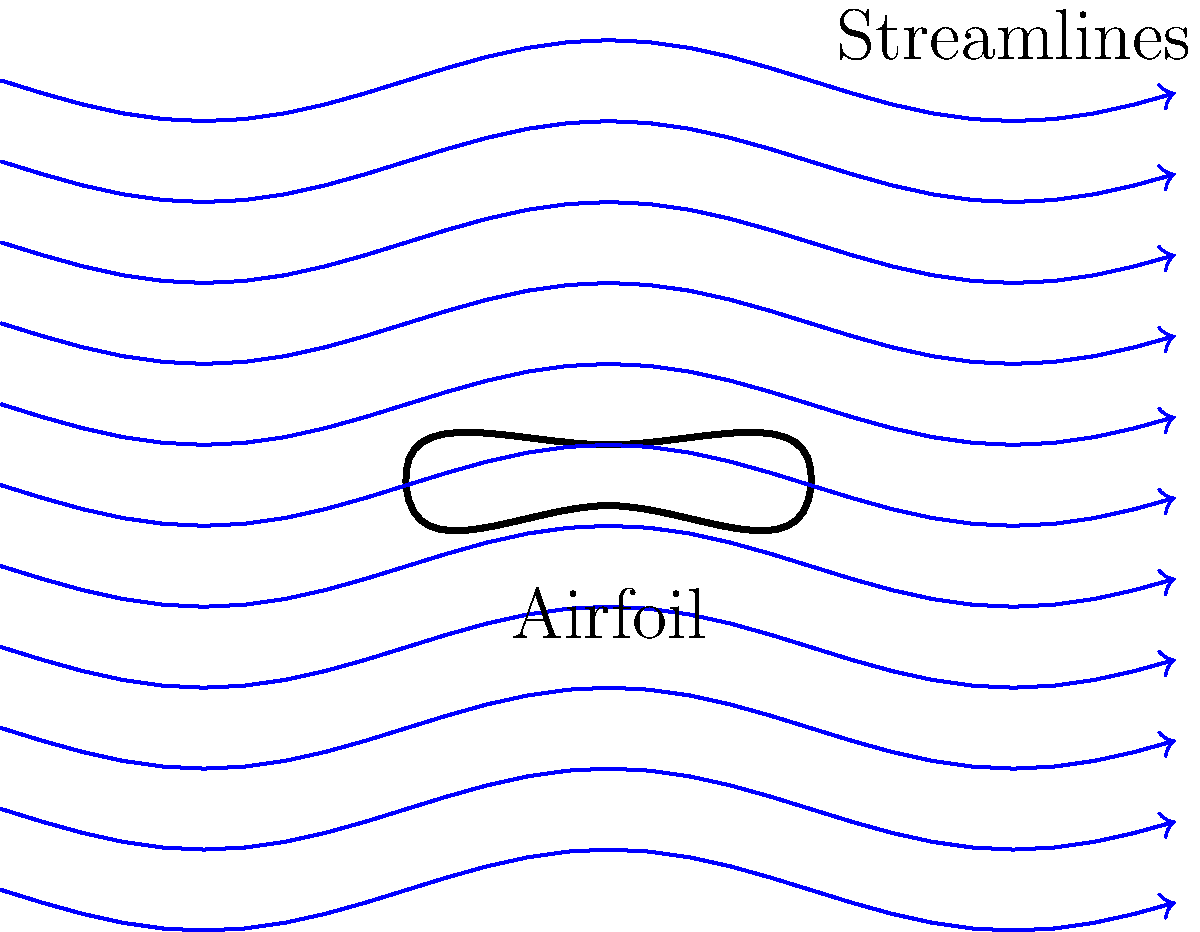In the diagram above, streamlines are used to visualize fluid flow around an airfoil. What characteristic of the streamlines near the top surface of the airfoil suggests a region of higher velocity compared to the bottom surface? To answer this question, we need to analyze the streamline patterns around the airfoil:

1. Observe the streamlines: Notice how they curve around the airfoil shape.

2. Compare top and bottom surfaces: The streamlines above the airfoil are closer together than those below.

3. Recall the continuity equation: For incompressible flow, $Q = A_1v_1 = A_2v_2$, where $Q$ is flow rate, $A$ is cross-sectional area, and $v$ is velocity.

4. Apply continuity to streamlines: When streamlines are closer together, it represents a smaller cross-sectional area ($A$).

5. Relate area to velocity: To maintain constant flow rate ($Q$), velocity ($v$) must increase as area ($A$) decreases.

6. Conclude: The closer spacing of streamlines on the top surface indicates a region of higher velocity compared to the bottom surface.

This phenomenon is crucial for generating lift in airfoils, as the pressure difference between top and bottom surfaces results from this velocity difference (Bernoulli's principle).
Answer: Closer spacing of streamlines 